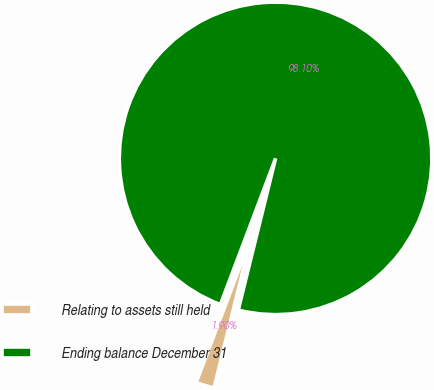Convert chart to OTSL. <chart><loc_0><loc_0><loc_500><loc_500><pie_chart><fcel>Relating to assets still held<fcel>Ending balance December 31<nl><fcel>1.9%<fcel>98.1%<nl></chart> 